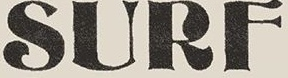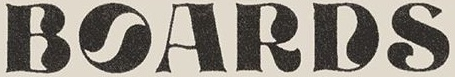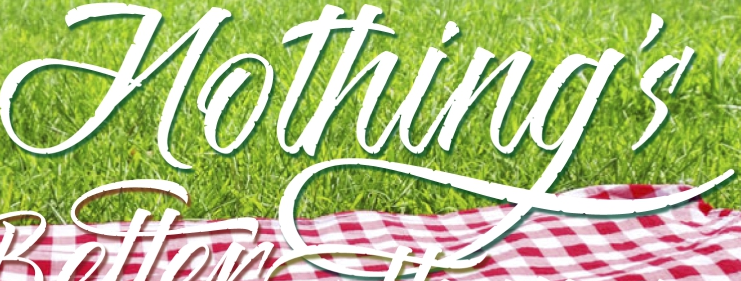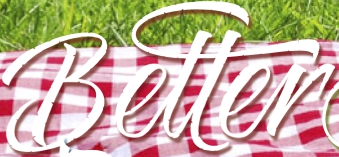What words can you see in these images in sequence, separated by a semicolon? SURF; BOARDS; Hothing's; Better 